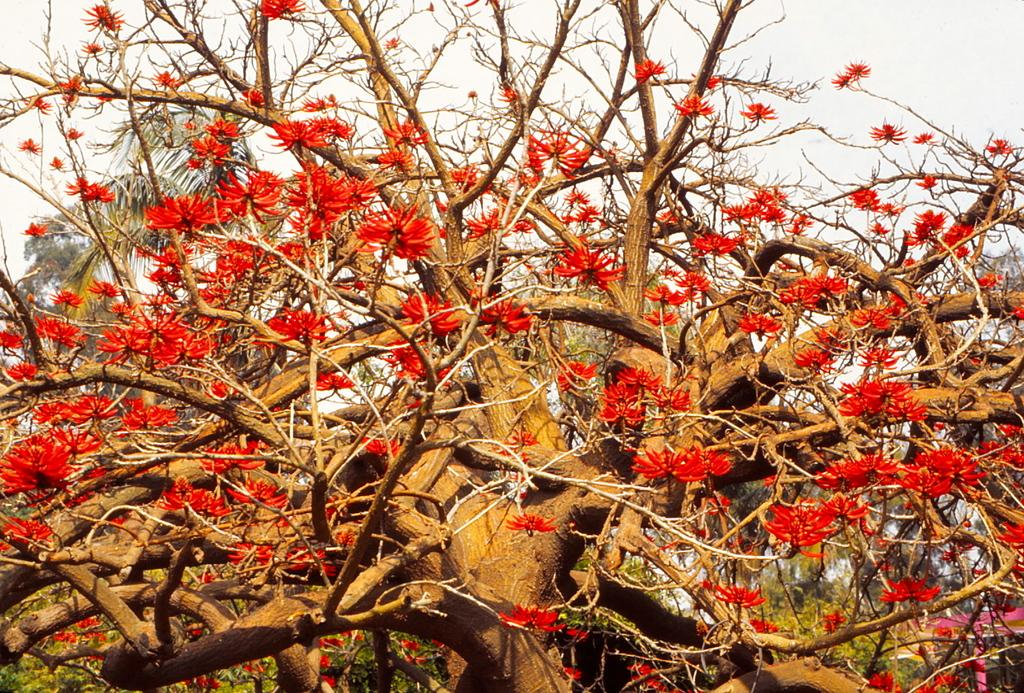What type of plant can be seen in the image? There is a tree in the image. What is special about the tree in the image? The tree has flowers. What is visible at the top of the image? The sky is visible at the top of the image. What type of hat is hanging from the tree in the image? There is no hat present in the image; it features a tree with flowers. What type of magic can be seen being performed on the tree in the image? There is no magic being performed in the image; it simply shows a tree with flowers. 